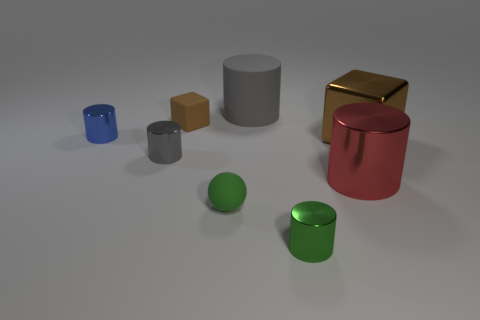How many gray cylinders must be subtracted to get 1 gray cylinders? 1 Subtract all blue metallic cylinders. How many cylinders are left? 4 Subtract all blue cylinders. How many cylinders are left? 4 Add 2 small blue metal cylinders. How many objects exist? 10 Subtract all red cylinders. Subtract all brown blocks. How many cylinders are left? 4 Subtract 0 red spheres. How many objects are left? 8 Subtract all balls. How many objects are left? 7 Subtract all green metallic objects. Subtract all blue cylinders. How many objects are left? 6 Add 4 green rubber balls. How many green rubber balls are left? 5 Add 8 small cyan metallic cylinders. How many small cyan metallic cylinders exist? 8 